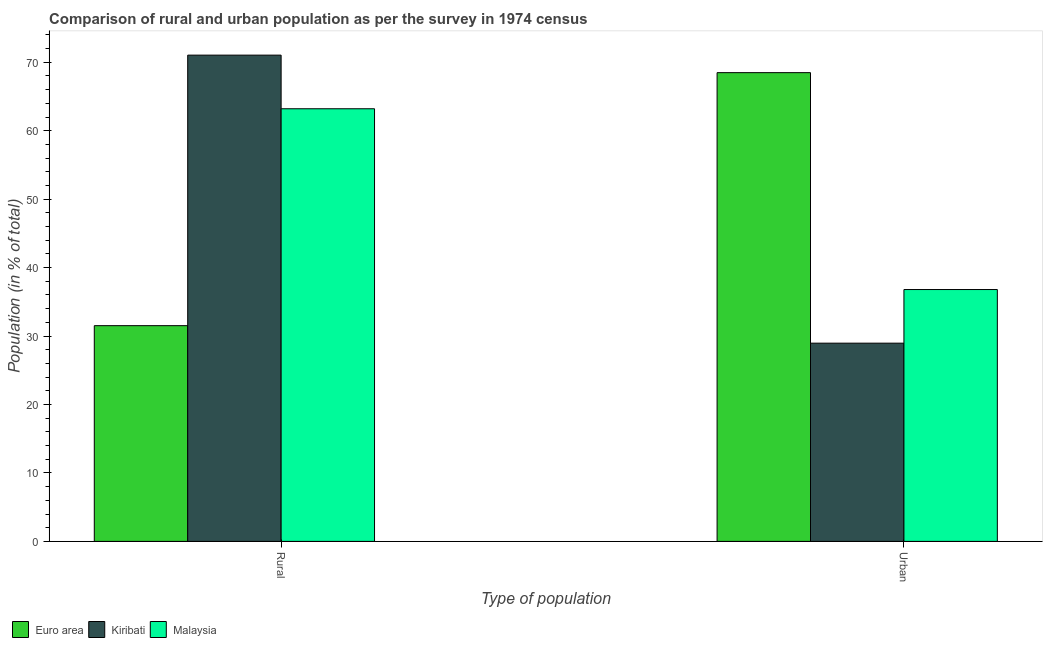How many different coloured bars are there?
Keep it short and to the point. 3. How many groups of bars are there?
Ensure brevity in your answer.  2. Are the number of bars per tick equal to the number of legend labels?
Ensure brevity in your answer.  Yes. How many bars are there on the 2nd tick from the left?
Make the answer very short. 3. How many bars are there on the 2nd tick from the right?
Your response must be concise. 3. What is the label of the 1st group of bars from the left?
Ensure brevity in your answer.  Rural. What is the rural population in Kiribati?
Offer a very short reply. 71.04. Across all countries, what is the maximum urban population?
Offer a very short reply. 68.48. Across all countries, what is the minimum rural population?
Your answer should be very brief. 31.52. In which country was the urban population maximum?
Ensure brevity in your answer.  Euro area. In which country was the urban population minimum?
Your answer should be compact. Kiribati. What is the total rural population in the graph?
Give a very brief answer. 165.76. What is the difference between the rural population in Malaysia and that in Euro area?
Ensure brevity in your answer.  31.69. What is the difference between the rural population in Euro area and the urban population in Malaysia?
Offer a very short reply. -5.28. What is the average urban population per country?
Give a very brief answer. 44.75. What is the difference between the urban population and rural population in Kiribati?
Ensure brevity in your answer.  -42.08. In how many countries, is the urban population greater than 64 %?
Provide a short and direct response. 1. What is the ratio of the rural population in Malaysia to that in Euro area?
Offer a terse response. 2.01. In how many countries, is the rural population greater than the average rural population taken over all countries?
Ensure brevity in your answer.  2. What does the 2nd bar from the left in Rural represents?
Offer a very short reply. Kiribati. What does the 3rd bar from the right in Rural represents?
Your answer should be compact. Euro area. Does the graph contain grids?
Your answer should be compact. No. Where does the legend appear in the graph?
Give a very brief answer. Bottom left. How many legend labels are there?
Offer a terse response. 3. How are the legend labels stacked?
Your answer should be compact. Horizontal. What is the title of the graph?
Provide a short and direct response. Comparison of rural and urban population as per the survey in 1974 census. Does "European Union" appear as one of the legend labels in the graph?
Offer a very short reply. No. What is the label or title of the X-axis?
Offer a terse response. Type of population. What is the label or title of the Y-axis?
Ensure brevity in your answer.  Population (in % of total). What is the Population (in % of total) in Euro area in Rural?
Offer a terse response. 31.52. What is the Population (in % of total) in Kiribati in Rural?
Your answer should be very brief. 71.04. What is the Population (in % of total) of Malaysia in Rural?
Provide a succinct answer. 63.21. What is the Population (in % of total) in Euro area in Urban?
Offer a very short reply. 68.48. What is the Population (in % of total) in Kiribati in Urban?
Keep it short and to the point. 28.96. What is the Population (in % of total) in Malaysia in Urban?
Your answer should be very brief. 36.79. Across all Type of population, what is the maximum Population (in % of total) in Euro area?
Make the answer very short. 68.48. Across all Type of population, what is the maximum Population (in % of total) in Kiribati?
Offer a terse response. 71.04. Across all Type of population, what is the maximum Population (in % of total) in Malaysia?
Provide a succinct answer. 63.21. Across all Type of population, what is the minimum Population (in % of total) in Euro area?
Your response must be concise. 31.52. Across all Type of population, what is the minimum Population (in % of total) in Kiribati?
Offer a terse response. 28.96. Across all Type of population, what is the minimum Population (in % of total) in Malaysia?
Make the answer very short. 36.79. What is the total Population (in % of total) of Euro area in the graph?
Offer a very short reply. 100. What is the difference between the Population (in % of total) in Euro area in Rural and that in Urban?
Provide a short and direct response. -36.96. What is the difference between the Population (in % of total) in Kiribati in Rural and that in Urban?
Your answer should be very brief. 42.08. What is the difference between the Population (in % of total) in Malaysia in Rural and that in Urban?
Ensure brevity in your answer.  26.41. What is the difference between the Population (in % of total) of Euro area in Rural and the Population (in % of total) of Kiribati in Urban?
Provide a short and direct response. 2.56. What is the difference between the Population (in % of total) in Euro area in Rural and the Population (in % of total) in Malaysia in Urban?
Your response must be concise. -5.28. What is the difference between the Population (in % of total) in Kiribati in Rural and the Population (in % of total) in Malaysia in Urban?
Your answer should be very brief. 34.25. What is the average Population (in % of total) of Euro area per Type of population?
Ensure brevity in your answer.  50. What is the average Population (in % of total) in Kiribati per Type of population?
Provide a succinct answer. 50. What is the average Population (in % of total) of Malaysia per Type of population?
Provide a succinct answer. 50. What is the difference between the Population (in % of total) in Euro area and Population (in % of total) in Kiribati in Rural?
Provide a short and direct response. -39.52. What is the difference between the Population (in % of total) in Euro area and Population (in % of total) in Malaysia in Rural?
Your response must be concise. -31.69. What is the difference between the Population (in % of total) in Kiribati and Population (in % of total) in Malaysia in Rural?
Provide a short and direct response. 7.83. What is the difference between the Population (in % of total) in Euro area and Population (in % of total) in Kiribati in Urban?
Make the answer very short. 39.52. What is the difference between the Population (in % of total) of Euro area and Population (in % of total) of Malaysia in Urban?
Ensure brevity in your answer.  31.69. What is the difference between the Population (in % of total) of Kiribati and Population (in % of total) of Malaysia in Urban?
Your response must be concise. -7.83. What is the ratio of the Population (in % of total) in Euro area in Rural to that in Urban?
Your response must be concise. 0.46. What is the ratio of the Population (in % of total) of Kiribati in Rural to that in Urban?
Offer a very short reply. 2.45. What is the ratio of the Population (in % of total) of Malaysia in Rural to that in Urban?
Ensure brevity in your answer.  1.72. What is the difference between the highest and the second highest Population (in % of total) in Euro area?
Give a very brief answer. 36.96. What is the difference between the highest and the second highest Population (in % of total) of Kiribati?
Ensure brevity in your answer.  42.08. What is the difference between the highest and the second highest Population (in % of total) in Malaysia?
Offer a very short reply. 26.41. What is the difference between the highest and the lowest Population (in % of total) in Euro area?
Provide a short and direct response. 36.96. What is the difference between the highest and the lowest Population (in % of total) in Kiribati?
Provide a short and direct response. 42.08. What is the difference between the highest and the lowest Population (in % of total) of Malaysia?
Your response must be concise. 26.41. 